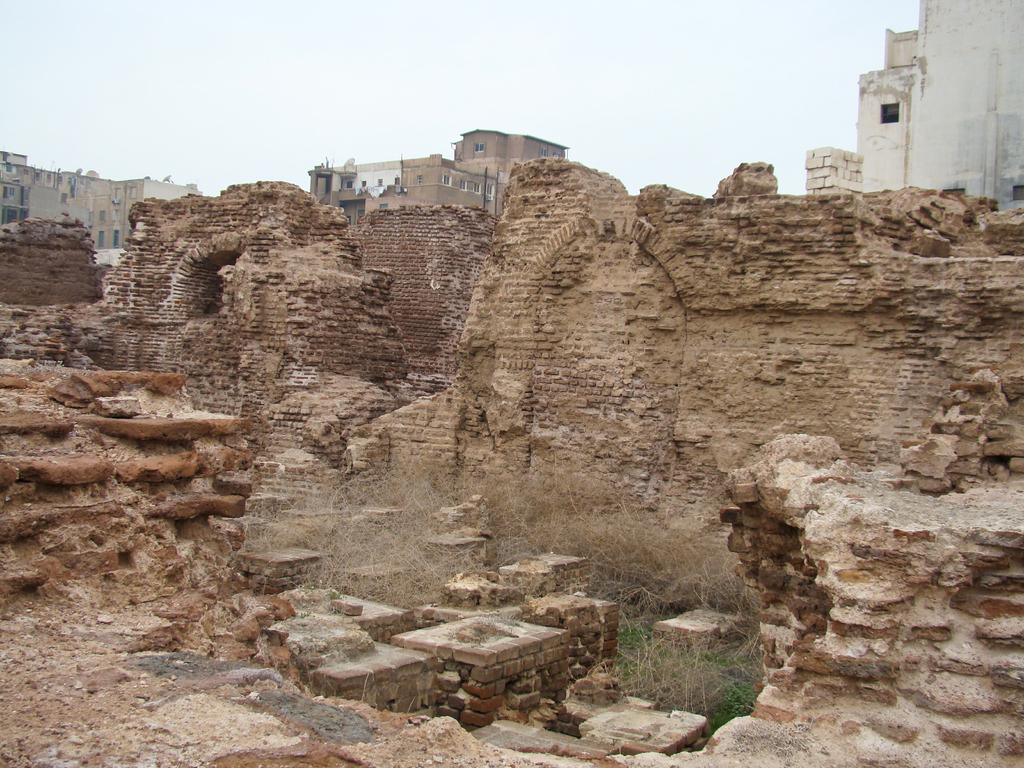What type of structures can be seen in the background of the image? There are buildings in the background of the image. What is located in the front of the image? There are stones in the front of the image. What is in the center of the image? There is a wall in the center of the image. What month is depicted in the image? There is no specific month depicted in the image; it is a static scene featuring buildings, stones, and a wall. Can you describe the snail's behavior in the image? There are no snails present in the image, so their behavior cannot be described. 